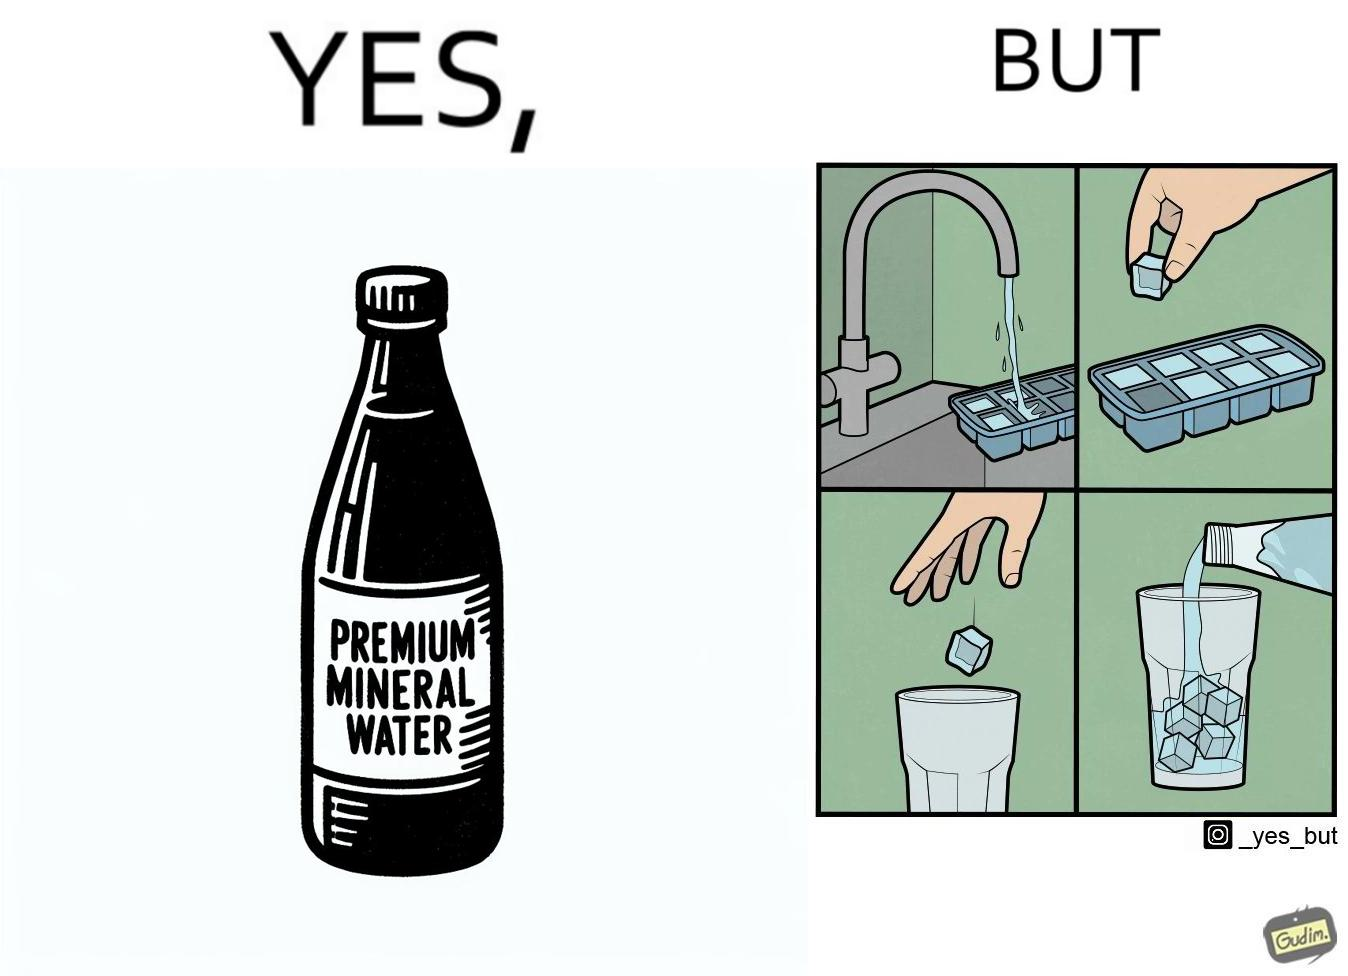Is there satirical content in this image? Yes, this image is satirical. 